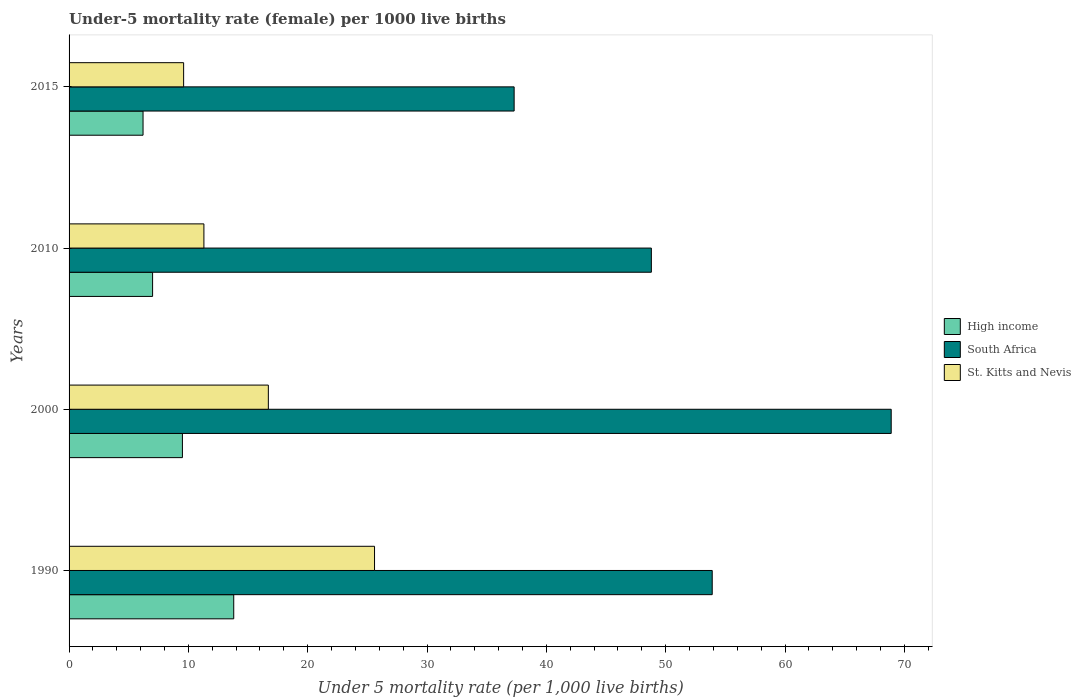Are the number of bars on each tick of the Y-axis equal?
Your answer should be very brief. Yes. Across all years, what is the minimum under-five mortality rate in St. Kitts and Nevis?
Ensure brevity in your answer.  9.6. In which year was the under-five mortality rate in High income maximum?
Give a very brief answer. 1990. In which year was the under-five mortality rate in High income minimum?
Your answer should be very brief. 2015. What is the total under-five mortality rate in St. Kitts and Nevis in the graph?
Give a very brief answer. 63.2. What is the difference between the under-five mortality rate in South Africa in 1990 and that in 2000?
Keep it short and to the point. -15. What is the difference between the under-five mortality rate in South Africa in 1990 and the under-five mortality rate in High income in 2015?
Provide a short and direct response. 47.7. What is the average under-five mortality rate in High income per year?
Give a very brief answer. 9.12. In the year 2015, what is the difference between the under-five mortality rate in High income and under-five mortality rate in St. Kitts and Nevis?
Ensure brevity in your answer.  -3.4. What is the ratio of the under-five mortality rate in High income in 1990 to that in 2000?
Your answer should be very brief. 1.45. Is the under-five mortality rate in St. Kitts and Nevis in 1990 less than that in 2010?
Your answer should be compact. No. What is the difference between the highest and the second highest under-five mortality rate in High income?
Your answer should be very brief. 4.3. What is the difference between the highest and the lowest under-five mortality rate in High income?
Offer a terse response. 7.6. What does the 1st bar from the top in 2015 represents?
Keep it short and to the point. St. Kitts and Nevis. What does the 3rd bar from the bottom in 2000 represents?
Offer a very short reply. St. Kitts and Nevis. Is it the case that in every year, the sum of the under-five mortality rate in High income and under-five mortality rate in St. Kitts and Nevis is greater than the under-five mortality rate in South Africa?
Provide a succinct answer. No. Are all the bars in the graph horizontal?
Your answer should be compact. Yes. How many years are there in the graph?
Make the answer very short. 4. Does the graph contain any zero values?
Your response must be concise. No. Does the graph contain grids?
Give a very brief answer. No. What is the title of the graph?
Provide a short and direct response. Under-5 mortality rate (female) per 1000 live births. Does "St. Martin (French part)" appear as one of the legend labels in the graph?
Provide a succinct answer. No. What is the label or title of the X-axis?
Your response must be concise. Under 5 mortality rate (per 1,0 live births). What is the label or title of the Y-axis?
Ensure brevity in your answer.  Years. What is the Under 5 mortality rate (per 1,000 live births) in High income in 1990?
Make the answer very short. 13.8. What is the Under 5 mortality rate (per 1,000 live births) of South Africa in 1990?
Your response must be concise. 53.9. What is the Under 5 mortality rate (per 1,000 live births) in St. Kitts and Nevis in 1990?
Your response must be concise. 25.6. What is the Under 5 mortality rate (per 1,000 live births) in South Africa in 2000?
Offer a terse response. 68.9. What is the Under 5 mortality rate (per 1,000 live births) in St. Kitts and Nevis in 2000?
Offer a very short reply. 16.7. What is the Under 5 mortality rate (per 1,000 live births) of South Africa in 2010?
Provide a short and direct response. 48.8. What is the Under 5 mortality rate (per 1,000 live births) of St. Kitts and Nevis in 2010?
Provide a succinct answer. 11.3. What is the Under 5 mortality rate (per 1,000 live births) of South Africa in 2015?
Offer a terse response. 37.3. What is the Under 5 mortality rate (per 1,000 live births) of St. Kitts and Nevis in 2015?
Provide a short and direct response. 9.6. Across all years, what is the maximum Under 5 mortality rate (per 1,000 live births) in High income?
Your answer should be very brief. 13.8. Across all years, what is the maximum Under 5 mortality rate (per 1,000 live births) of South Africa?
Provide a short and direct response. 68.9. Across all years, what is the maximum Under 5 mortality rate (per 1,000 live births) in St. Kitts and Nevis?
Your answer should be compact. 25.6. Across all years, what is the minimum Under 5 mortality rate (per 1,000 live births) in High income?
Your answer should be very brief. 6.2. Across all years, what is the minimum Under 5 mortality rate (per 1,000 live births) of South Africa?
Ensure brevity in your answer.  37.3. What is the total Under 5 mortality rate (per 1,000 live births) in High income in the graph?
Make the answer very short. 36.5. What is the total Under 5 mortality rate (per 1,000 live births) in South Africa in the graph?
Offer a terse response. 208.9. What is the total Under 5 mortality rate (per 1,000 live births) in St. Kitts and Nevis in the graph?
Provide a short and direct response. 63.2. What is the difference between the Under 5 mortality rate (per 1,000 live births) in South Africa in 1990 and that in 2000?
Make the answer very short. -15. What is the difference between the Under 5 mortality rate (per 1,000 live births) of High income in 1990 and that in 2010?
Make the answer very short. 6.8. What is the difference between the Under 5 mortality rate (per 1,000 live births) of St. Kitts and Nevis in 1990 and that in 2010?
Ensure brevity in your answer.  14.3. What is the difference between the Under 5 mortality rate (per 1,000 live births) in South Africa in 1990 and that in 2015?
Your answer should be compact. 16.6. What is the difference between the Under 5 mortality rate (per 1,000 live births) of St. Kitts and Nevis in 1990 and that in 2015?
Provide a succinct answer. 16. What is the difference between the Under 5 mortality rate (per 1,000 live births) of South Africa in 2000 and that in 2010?
Your answer should be very brief. 20.1. What is the difference between the Under 5 mortality rate (per 1,000 live births) of High income in 2000 and that in 2015?
Your answer should be very brief. 3.3. What is the difference between the Under 5 mortality rate (per 1,000 live births) in South Africa in 2000 and that in 2015?
Give a very brief answer. 31.6. What is the difference between the Under 5 mortality rate (per 1,000 live births) in St. Kitts and Nevis in 2000 and that in 2015?
Offer a very short reply. 7.1. What is the difference between the Under 5 mortality rate (per 1,000 live births) in South Africa in 2010 and that in 2015?
Provide a short and direct response. 11.5. What is the difference between the Under 5 mortality rate (per 1,000 live births) of High income in 1990 and the Under 5 mortality rate (per 1,000 live births) of South Africa in 2000?
Ensure brevity in your answer.  -55.1. What is the difference between the Under 5 mortality rate (per 1,000 live births) in South Africa in 1990 and the Under 5 mortality rate (per 1,000 live births) in St. Kitts and Nevis in 2000?
Ensure brevity in your answer.  37.2. What is the difference between the Under 5 mortality rate (per 1,000 live births) of High income in 1990 and the Under 5 mortality rate (per 1,000 live births) of South Africa in 2010?
Ensure brevity in your answer.  -35. What is the difference between the Under 5 mortality rate (per 1,000 live births) in High income in 1990 and the Under 5 mortality rate (per 1,000 live births) in St. Kitts and Nevis in 2010?
Offer a very short reply. 2.5. What is the difference between the Under 5 mortality rate (per 1,000 live births) of South Africa in 1990 and the Under 5 mortality rate (per 1,000 live births) of St. Kitts and Nevis in 2010?
Provide a succinct answer. 42.6. What is the difference between the Under 5 mortality rate (per 1,000 live births) in High income in 1990 and the Under 5 mortality rate (per 1,000 live births) in South Africa in 2015?
Keep it short and to the point. -23.5. What is the difference between the Under 5 mortality rate (per 1,000 live births) in South Africa in 1990 and the Under 5 mortality rate (per 1,000 live births) in St. Kitts and Nevis in 2015?
Your response must be concise. 44.3. What is the difference between the Under 5 mortality rate (per 1,000 live births) in High income in 2000 and the Under 5 mortality rate (per 1,000 live births) in South Africa in 2010?
Make the answer very short. -39.3. What is the difference between the Under 5 mortality rate (per 1,000 live births) in High income in 2000 and the Under 5 mortality rate (per 1,000 live births) in St. Kitts and Nevis in 2010?
Provide a short and direct response. -1.8. What is the difference between the Under 5 mortality rate (per 1,000 live births) of South Africa in 2000 and the Under 5 mortality rate (per 1,000 live births) of St. Kitts and Nevis in 2010?
Offer a very short reply. 57.6. What is the difference between the Under 5 mortality rate (per 1,000 live births) in High income in 2000 and the Under 5 mortality rate (per 1,000 live births) in South Africa in 2015?
Your answer should be very brief. -27.8. What is the difference between the Under 5 mortality rate (per 1,000 live births) of High income in 2000 and the Under 5 mortality rate (per 1,000 live births) of St. Kitts and Nevis in 2015?
Provide a short and direct response. -0.1. What is the difference between the Under 5 mortality rate (per 1,000 live births) in South Africa in 2000 and the Under 5 mortality rate (per 1,000 live births) in St. Kitts and Nevis in 2015?
Your answer should be compact. 59.3. What is the difference between the Under 5 mortality rate (per 1,000 live births) in High income in 2010 and the Under 5 mortality rate (per 1,000 live births) in South Africa in 2015?
Provide a succinct answer. -30.3. What is the difference between the Under 5 mortality rate (per 1,000 live births) of South Africa in 2010 and the Under 5 mortality rate (per 1,000 live births) of St. Kitts and Nevis in 2015?
Provide a succinct answer. 39.2. What is the average Under 5 mortality rate (per 1,000 live births) of High income per year?
Keep it short and to the point. 9.12. What is the average Under 5 mortality rate (per 1,000 live births) in South Africa per year?
Your response must be concise. 52.23. What is the average Under 5 mortality rate (per 1,000 live births) of St. Kitts and Nevis per year?
Make the answer very short. 15.8. In the year 1990, what is the difference between the Under 5 mortality rate (per 1,000 live births) of High income and Under 5 mortality rate (per 1,000 live births) of South Africa?
Provide a succinct answer. -40.1. In the year 1990, what is the difference between the Under 5 mortality rate (per 1,000 live births) in South Africa and Under 5 mortality rate (per 1,000 live births) in St. Kitts and Nevis?
Offer a very short reply. 28.3. In the year 2000, what is the difference between the Under 5 mortality rate (per 1,000 live births) in High income and Under 5 mortality rate (per 1,000 live births) in South Africa?
Your response must be concise. -59.4. In the year 2000, what is the difference between the Under 5 mortality rate (per 1,000 live births) in South Africa and Under 5 mortality rate (per 1,000 live births) in St. Kitts and Nevis?
Give a very brief answer. 52.2. In the year 2010, what is the difference between the Under 5 mortality rate (per 1,000 live births) in High income and Under 5 mortality rate (per 1,000 live births) in South Africa?
Make the answer very short. -41.8. In the year 2010, what is the difference between the Under 5 mortality rate (per 1,000 live births) in South Africa and Under 5 mortality rate (per 1,000 live births) in St. Kitts and Nevis?
Give a very brief answer. 37.5. In the year 2015, what is the difference between the Under 5 mortality rate (per 1,000 live births) of High income and Under 5 mortality rate (per 1,000 live births) of South Africa?
Keep it short and to the point. -31.1. In the year 2015, what is the difference between the Under 5 mortality rate (per 1,000 live births) of South Africa and Under 5 mortality rate (per 1,000 live births) of St. Kitts and Nevis?
Offer a very short reply. 27.7. What is the ratio of the Under 5 mortality rate (per 1,000 live births) in High income in 1990 to that in 2000?
Provide a succinct answer. 1.45. What is the ratio of the Under 5 mortality rate (per 1,000 live births) of South Africa in 1990 to that in 2000?
Provide a succinct answer. 0.78. What is the ratio of the Under 5 mortality rate (per 1,000 live births) of St. Kitts and Nevis in 1990 to that in 2000?
Ensure brevity in your answer.  1.53. What is the ratio of the Under 5 mortality rate (per 1,000 live births) of High income in 1990 to that in 2010?
Provide a succinct answer. 1.97. What is the ratio of the Under 5 mortality rate (per 1,000 live births) of South Africa in 1990 to that in 2010?
Provide a short and direct response. 1.1. What is the ratio of the Under 5 mortality rate (per 1,000 live births) of St. Kitts and Nevis in 1990 to that in 2010?
Your answer should be compact. 2.27. What is the ratio of the Under 5 mortality rate (per 1,000 live births) of High income in 1990 to that in 2015?
Provide a succinct answer. 2.23. What is the ratio of the Under 5 mortality rate (per 1,000 live births) in South Africa in 1990 to that in 2015?
Your answer should be compact. 1.45. What is the ratio of the Under 5 mortality rate (per 1,000 live births) of St. Kitts and Nevis in 1990 to that in 2015?
Provide a succinct answer. 2.67. What is the ratio of the Under 5 mortality rate (per 1,000 live births) of High income in 2000 to that in 2010?
Provide a short and direct response. 1.36. What is the ratio of the Under 5 mortality rate (per 1,000 live births) of South Africa in 2000 to that in 2010?
Provide a short and direct response. 1.41. What is the ratio of the Under 5 mortality rate (per 1,000 live births) of St. Kitts and Nevis in 2000 to that in 2010?
Give a very brief answer. 1.48. What is the ratio of the Under 5 mortality rate (per 1,000 live births) in High income in 2000 to that in 2015?
Your answer should be compact. 1.53. What is the ratio of the Under 5 mortality rate (per 1,000 live births) in South Africa in 2000 to that in 2015?
Your answer should be very brief. 1.85. What is the ratio of the Under 5 mortality rate (per 1,000 live births) of St. Kitts and Nevis in 2000 to that in 2015?
Offer a very short reply. 1.74. What is the ratio of the Under 5 mortality rate (per 1,000 live births) in High income in 2010 to that in 2015?
Your answer should be very brief. 1.13. What is the ratio of the Under 5 mortality rate (per 1,000 live births) of South Africa in 2010 to that in 2015?
Keep it short and to the point. 1.31. What is the ratio of the Under 5 mortality rate (per 1,000 live births) of St. Kitts and Nevis in 2010 to that in 2015?
Your response must be concise. 1.18. What is the difference between the highest and the second highest Under 5 mortality rate (per 1,000 live births) in South Africa?
Give a very brief answer. 15. What is the difference between the highest and the second highest Under 5 mortality rate (per 1,000 live births) of St. Kitts and Nevis?
Keep it short and to the point. 8.9. What is the difference between the highest and the lowest Under 5 mortality rate (per 1,000 live births) in High income?
Your answer should be very brief. 7.6. What is the difference between the highest and the lowest Under 5 mortality rate (per 1,000 live births) in South Africa?
Give a very brief answer. 31.6. 